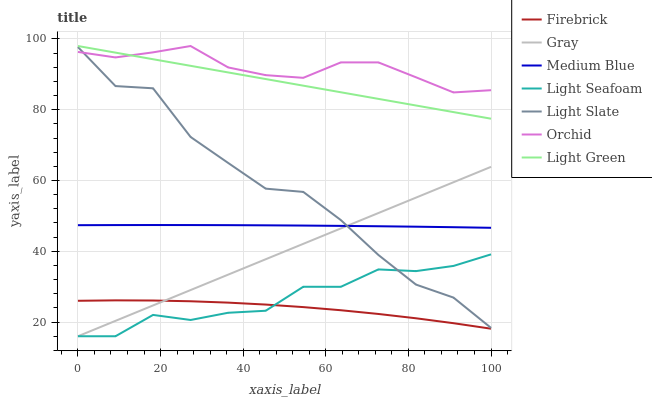Does Firebrick have the minimum area under the curve?
Answer yes or no. Yes. Does Orchid have the maximum area under the curve?
Answer yes or no. Yes. Does Light Slate have the minimum area under the curve?
Answer yes or no. No. Does Light Slate have the maximum area under the curve?
Answer yes or no. No. Is Gray the smoothest?
Answer yes or no. Yes. Is Light Slate the roughest?
Answer yes or no. Yes. Is Firebrick the smoothest?
Answer yes or no. No. Is Firebrick the roughest?
Answer yes or no. No. Does Gray have the lowest value?
Answer yes or no. Yes. Does Light Slate have the lowest value?
Answer yes or no. No. Does Light Green have the highest value?
Answer yes or no. Yes. Does Light Slate have the highest value?
Answer yes or no. No. Is Firebrick less than Medium Blue?
Answer yes or no. Yes. Is Light Green greater than Gray?
Answer yes or no. Yes. Does Light Seafoam intersect Gray?
Answer yes or no. Yes. Is Light Seafoam less than Gray?
Answer yes or no. No. Is Light Seafoam greater than Gray?
Answer yes or no. No. Does Firebrick intersect Medium Blue?
Answer yes or no. No. 